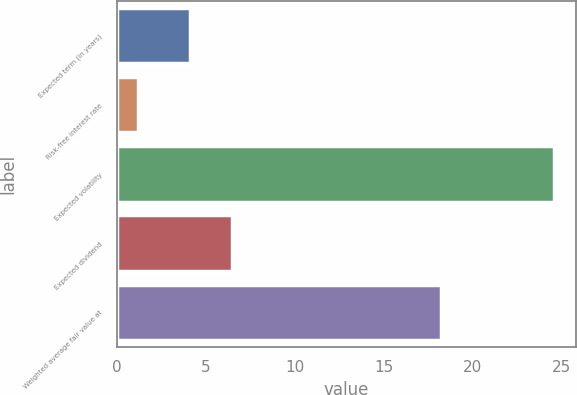Convert chart. <chart><loc_0><loc_0><loc_500><loc_500><bar_chart><fcel>Expected term (in years)<fcel>Risk-free interest rate<fcel>Expected volatility<fcel>Expected dividend<fcel>Weighted average fair value at<nl><fcel>4.13<fcel>1.2<fcel>24.6<fcel>6.47<fcel>18.24<nl></chart> 